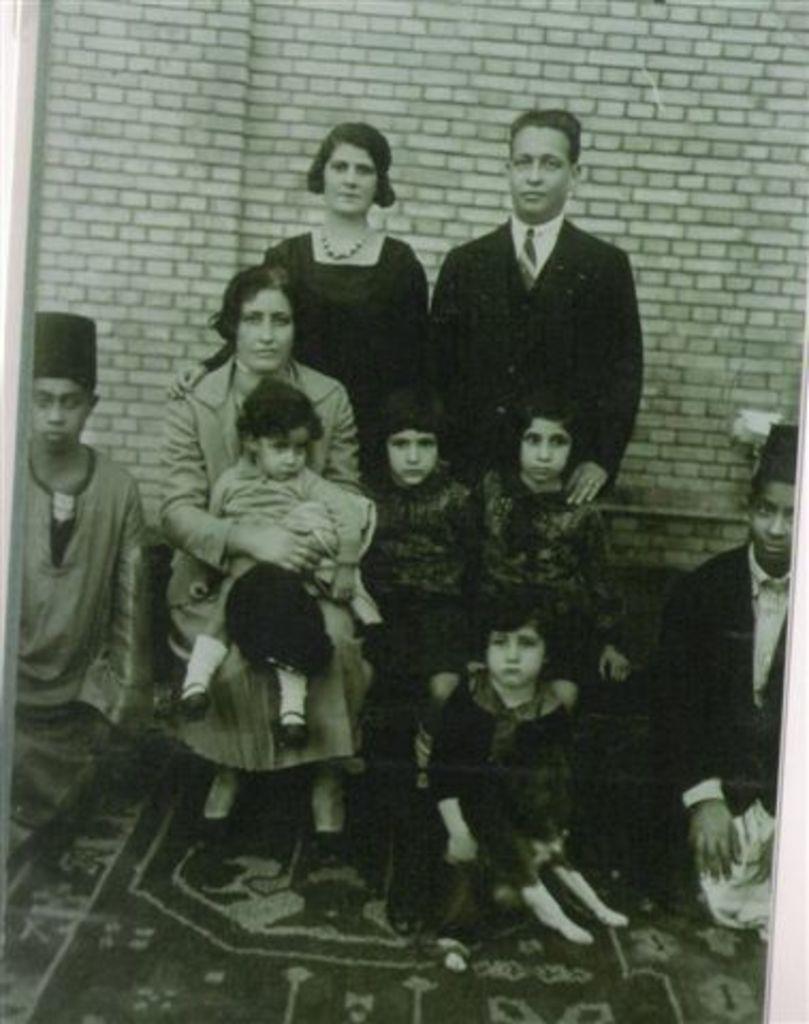How would you summarize this image in a sentence or two? in the given picture i can see group of the people who is sitting towards left and holding ,wearing a cap and middle person who is sitting and holding a baby and behind the middle person , they're two other persons who are standing and also i can see few others children's who are sitting here and behind those people there is a wall which is build with bricks and also i can see mat. 